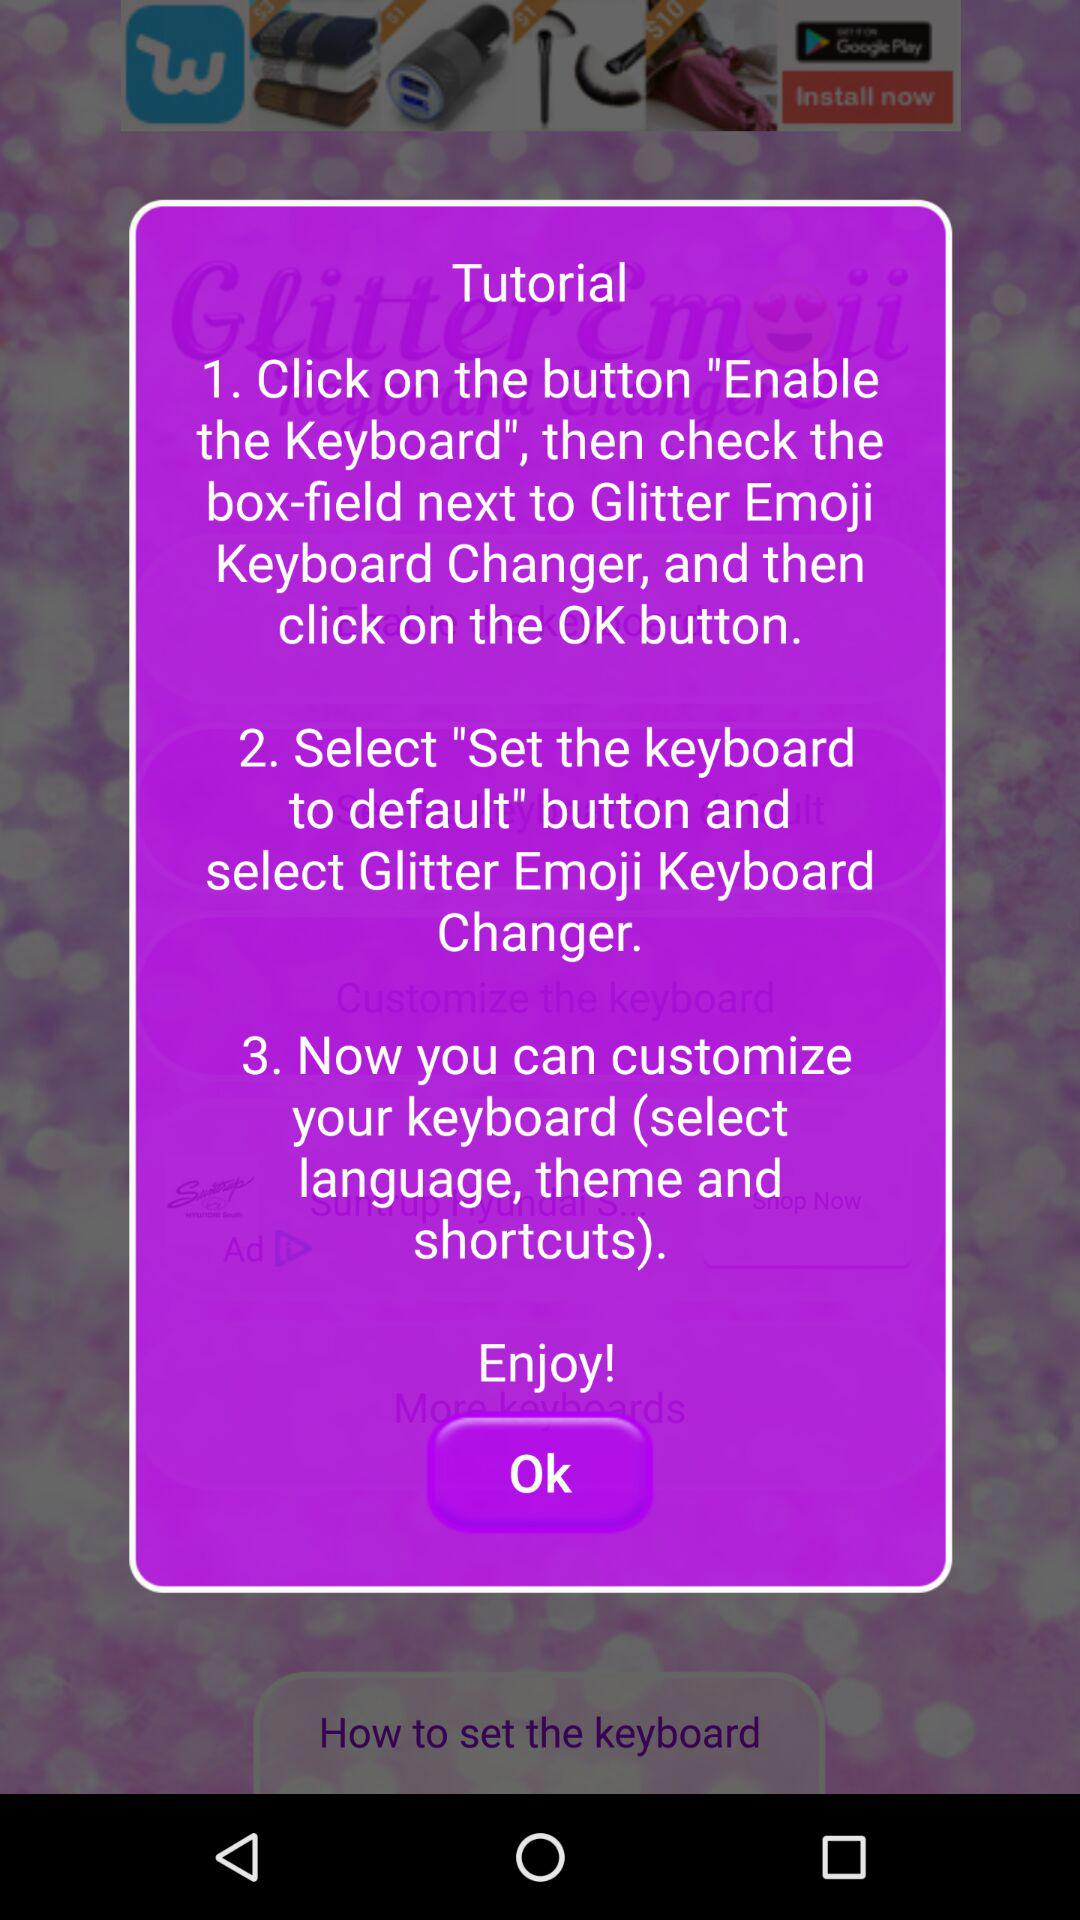What is the third step of the tutorial? The third step is "Now you can customize your keyboard (select language, theme and shortcuts)". 